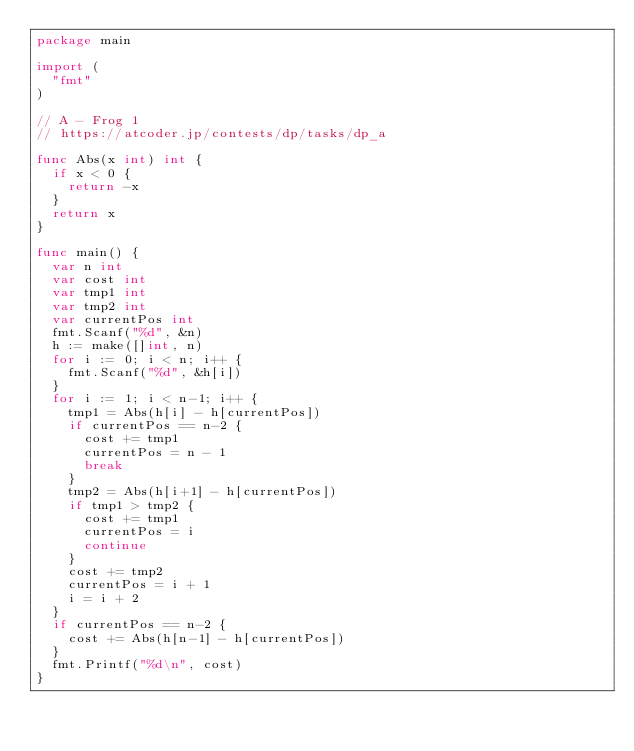Convert code to text. <code><loc_0><loc_0><loc_500><loc_500><_Go_>package main

import (
	"fmt"
)

// A - Frog 1
// https://atcoder.jp/contests/dp/tasks/dp_a

func Abs(x int) int {
	if x < 0 {
		return -x
	}
	return x
}

func main() {
	var n int
	var cost int
	var tmp1 int
	var tmp2 int
	var currentPos int
	fmt.Scanf("%d", &n)
	h := make([]int, n)
	for i := 0; i < n; i++ {
		fmt.Scanf("%d", &h[i])
	}
	for i := 1; i < n-1; i++ {
		tmp1 = Abs(h[i] - h[currentPos])
		if currentPos == n-2 {
			cost += tmp1
			currentPos = n - 1
			break
		}
		tmp2 = Abs(h[i+1] - h[currentPos])
		if tmp1 > tmp2 {
			cost += tmp1
			currentPos = i
			continue
		}
		cost += tmp2
		currentPos = i + 1
		i = i + 2
	}
	if currentPos == n-2 {
		cost += Abs(h[n-1] - h[currentPos])
	}
	fmt.Printf("%d\n", cost)
}
</code> 